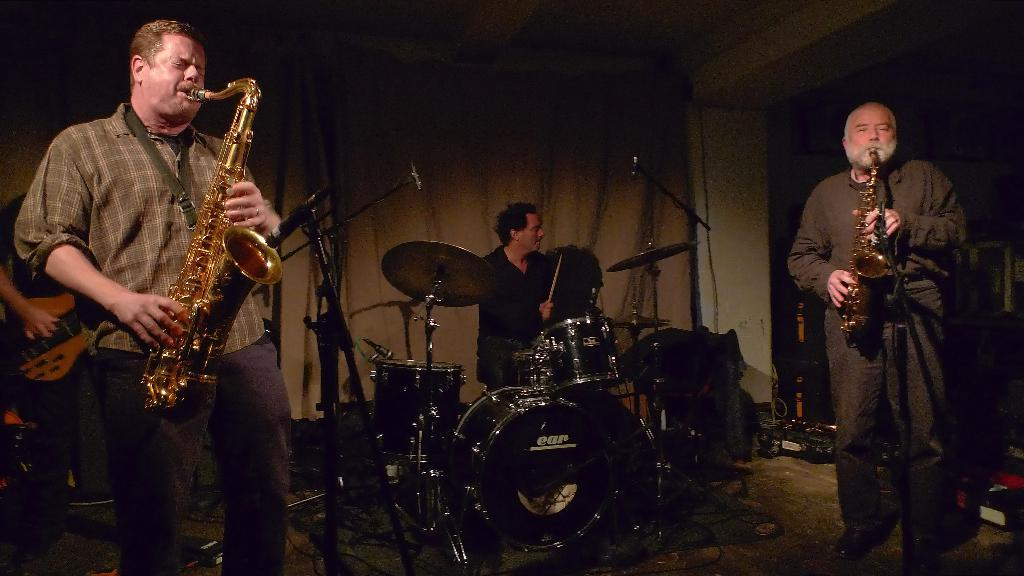What are the persons in the image doing? The persons in the image are performing. What are they using to perform? They are playing musical instruments. What can be seen on the stage with the performers? There are mics on a stand in the image. What is visible in the background of the image? There is a curtain, a wall, and other objects visible in the background of the image. What is the purpose of the attempt to process the vegetables in the image? There is no mention of vegetables or any attempt to process them in the image. The image features persons performing with musical instruments, mics on a stand, and a background with a curtain, a wall, and other objects. 